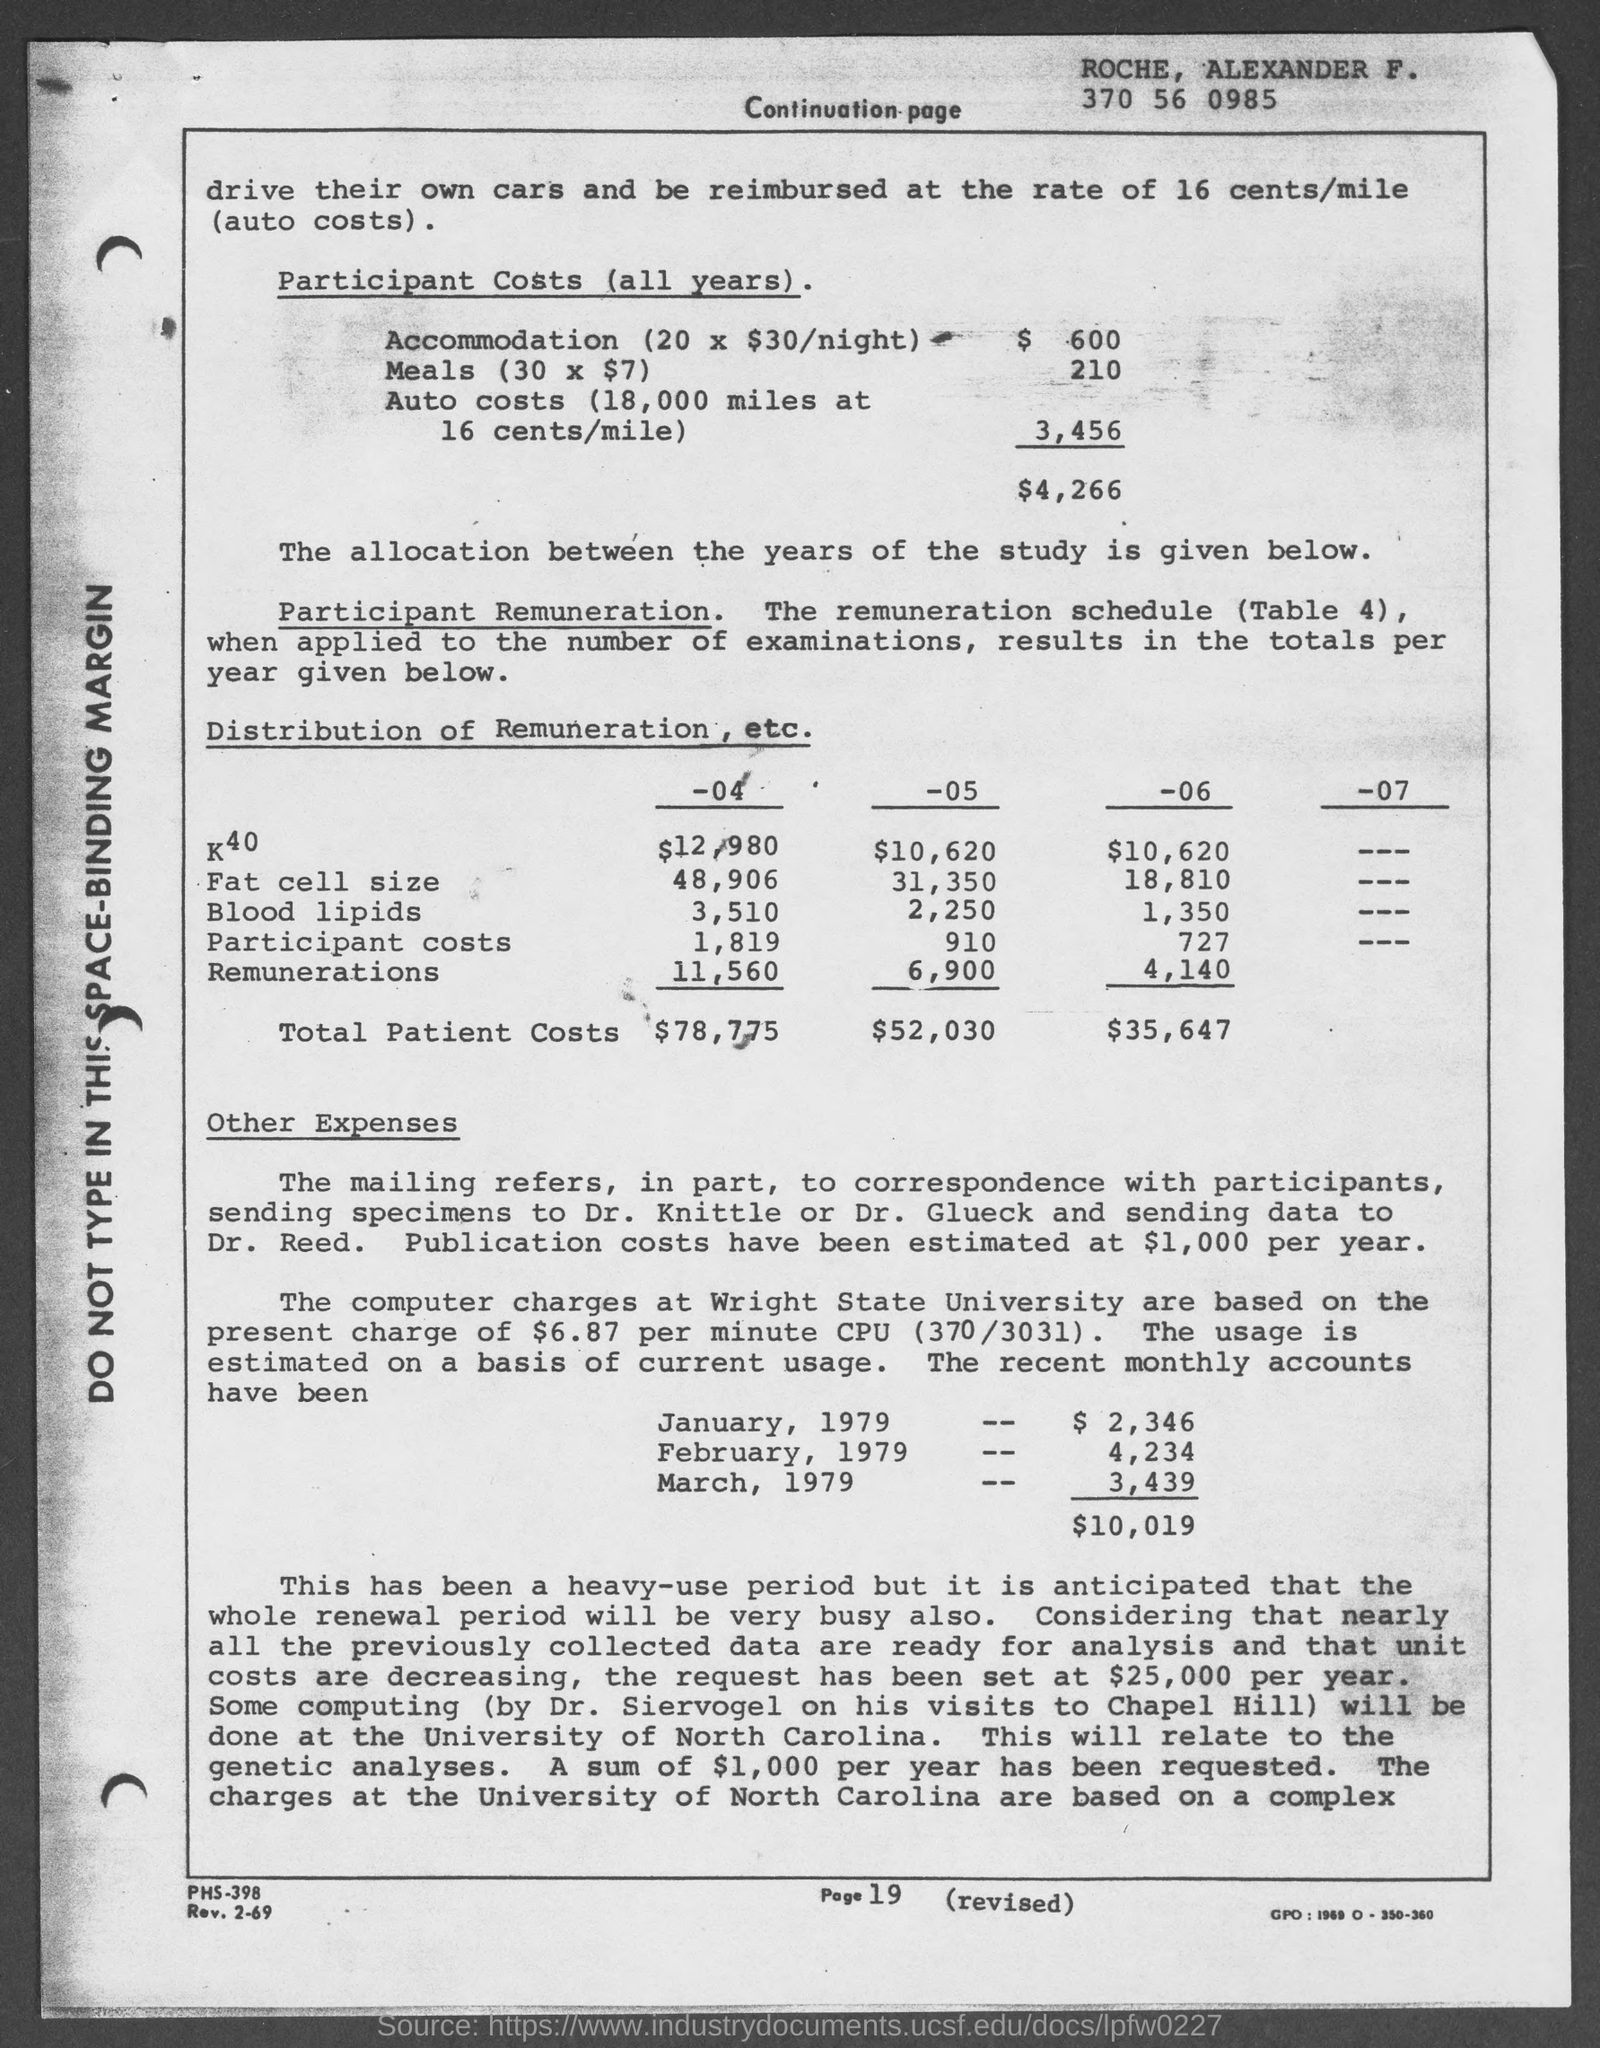Outline some significant characteristics in this image. The page number at the bottom of the page is 19. 